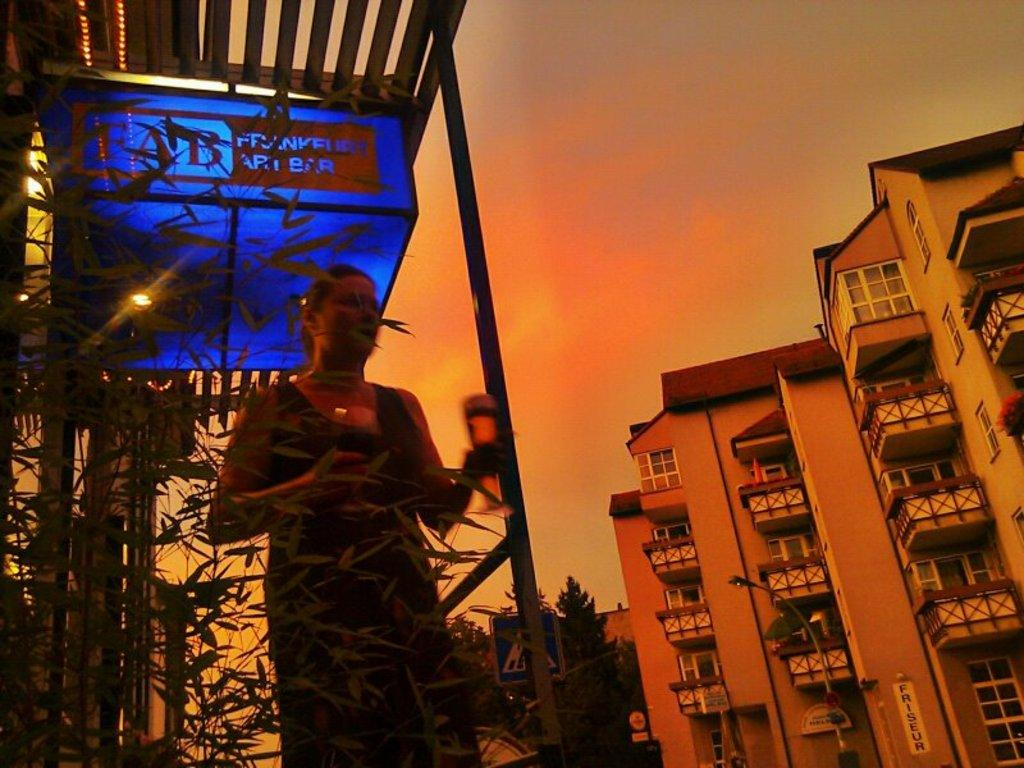Who is present in the image? There is a woman in the image. What can be seen on the right side of the image? There are buildings on the right side of the image. What type of lighting is present in the image? There are street lights in the image. What is the condition of the sky in the image? The sky is clear in the image. What type of scientific expansion is taking place in the image? There is no scientific expansion present in the image. What type of pan is visible in the image? There is no pan visible in the image. 